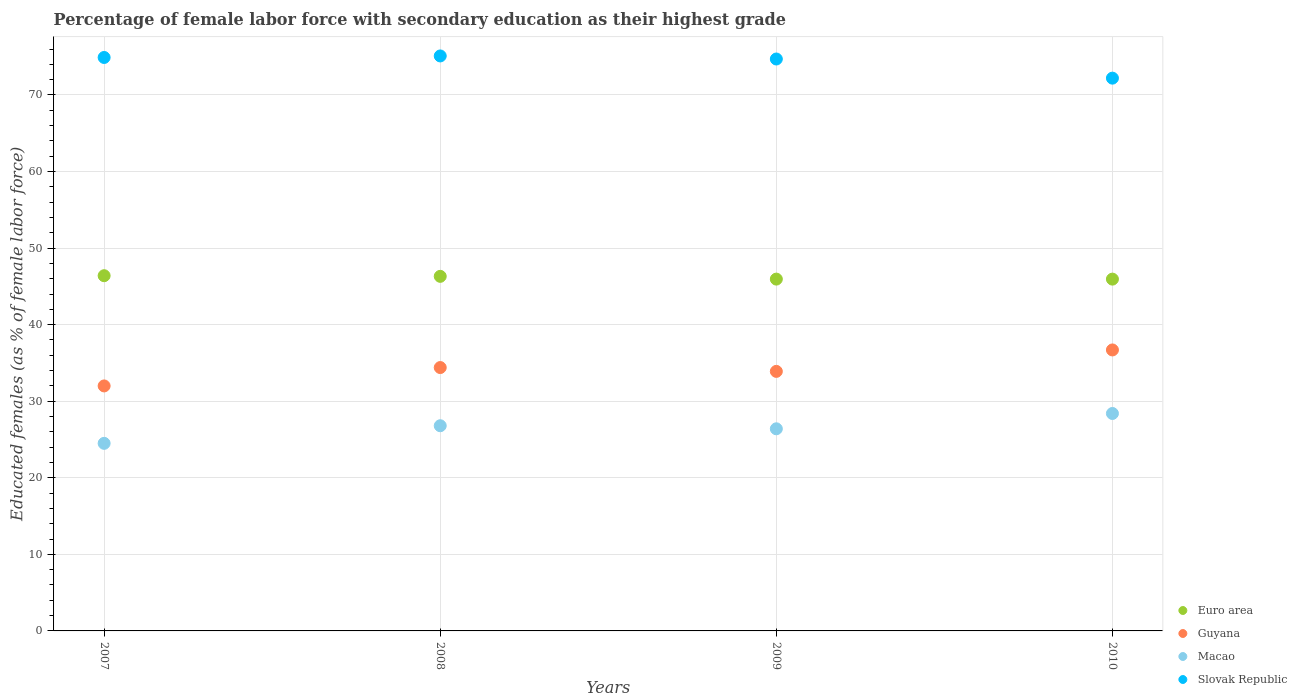Is the number of dotlines equal to the number of legend labels?
Your response must be concise. Yes. What is the percentage of female labor force with secondary education in Macao in 2009?
Offer a very short reply. 26.4. Across all years, what is the maximum percentage of female labor force with secondary education in Slovak Republic?
Your answer should be very brief. 75.1. In which year was the percentage of female labor force with secondary education in Guyana maximum?
Ensure brevity in your answer.  2010. In which year was the percentage of female labor force with secondary education in Euro area minimum?
Give a very brief answer. 2010. What is the total percentage of female labor force with secondary education in Macao in the graph?
Make the answer very short. 106.1. What is the difference between the percentage of female labor force with secondary education in Macao in 2007 and that in 2009?
Give a very brief answer. -1.9. What is the difference between the percentage of female labor force with secondary education in Macao in 2007 and the percentage of female labor force with secondary education in Guyana in 2010?
Offer a very short reply. -12.2. What is the average percentage of female labor force with secondary education in Slovak Republic per year?
Offer a very short reply. 74.22. In the year 2008, what is the difference between the percentage of female labor force with secondary education in Guyana and percentage of female labor force with secondary education in Euro area?
Keep it short and to the point. -11.91. In how many years, is the percentage of female labor force with secondary education in Guyana greater than 42 %?
Offer a very short reply. 0. What is the ratio of the percentage of female labor force with secondary education in Euro area in 2007 to that in 2009?
Your response must be concise. 1.01. What is the difference between the highest and the second highest percentage of female labor force with secondary education in Guyana?
Provide a succinct answer. 2.3. What is the difference between the highest and the lowest percentage of female labor force with secondary education in Slovak Republic?
Keep it short and to the point. 2.9. Is the sum of the percentage of female labor force with secondary education in Macao in 2007 and 2009 greater than the maximum percentage of female labor force with secondary education in Euro area across all years?
Make the answer very short. Yes. Is it the case that in every year, the sum of the percentage of female labor force with secondary education in Euro area and percentage of female labor force with secondary education in Guyana  is greater than the sum of percentage of female labor force with secondary education in Slovak Republic and percentage of female labor force with secondary education in Macao?
Your answer should be very brief. No. Is it the case that in every year, the sum of the percentage of female labor force with secondary education in Euro area and percentage of female labor force with secondary education in Guyana  is greater than the percentage of female labor force with secondary education in Slovak Republic?
Give a very brief answer. Yes. How many years are there in the graph?
Offer a terse response. 4. Does the graph contain any zero values?
Offer a very short reply. No. How many legend labels are there?
Provide a succinct answer. 4. How are the legend labels stacked?
Keep it short and to the point. Vertical. What is the title of the graph?
Your answer should be very brief. Percentage of female labor force with secondary education as their highest grade. What is the label or title of the Y-axis?
Provide a succinct answer. Educated females (as % of female labor force). What is the Educated females (as % of female labor force) in Euro area in 2007?
Your answer should be very brief. 46.4. What is the Educated females (as % of female labor force) of Guyana in 2007?
Your answer should be very brief. 32. What is the Educated females (as % of female labor force) in Slovak Republic in 2007?
Your response must be concise. 74.9. What is the Educated females (as % of female labor force) in Euro area in 2008?
Offer a very short reply. 46.31. What is the Educated females (as % of female labor force) in Guyana in 2008?
Your answer should be very brief. 34.4. What is the Educated females (as % of female labor force) in Macao in 2008?
Give a very brief answer. 26.8. What is the Educated females (as % of female labor force) in Slovak Republic in 2008?
Provide a succinct answer. 75.1. What is the Educated females (as % of female labor force) of Euro area in 2009?
Offer a very short reply. 45.95. What is the Educated females (as % of female labor force) of Guyana in 2009?
Your answer should be very brief. 33.9. What is the Educated females (as % of female labor force) of Macao in 2009?
Provide a succinct answer. 26.4. What is the Educated females (as % of female labor force) of Slovak Republic in 2009?
Ensure brevity in your answer.  74.7. What is the Educated females (as % of female labor force) of Euro area in 2010?
Give a very brief answer. 45.95. What is the Educated females (as % of female labor force) in Guyana in 2010?
Make the answer very short. 36.7. What is the Educated females (as % of female labor force) of Macao in 2010?
Offer a terse response. 28.4. What is the Educated females (as % of female labor force) of Slovak Republic in 2010?
Make the answer very short. 72.2. Across all years, what is the maximum Educated females (as % of female labor force) of Euro area?
Make the answer very short. 46.4. Across all years, what is the maximum Educated females (as % of female labor force) of Guyana?
Keep it short and to the point. 36.7. Across all years, what is the maximum Educated females (as % of female labor force) in Macao?
Keep it short and to the point. 28.4. Across all years, what is the maximum Educated females (as % of female labor force) of Slovak Republic?
Provide a succinct answer. 75.1. Across all years, what is the minimum Educated females (as % of female labor force) in Euro area?
Keep it short and to the point. 45.95. Across all years, what is the minimum Educated females (as % of female labor force) in Slovak Republic?
Give a very brief answer. 72.2. What is the total Educated females (as % of female labor force) in Euro area in the graph?
Offer a very short reply. 184.61. What is the total Educated females (as % of female labor force) in Guyana in the graph?
Your answer should be very brief. 137. What is the total Educated females (as % of female labor force) in Macao in the graph?
Your answer should be very brief. 106.1. What is the total Educated females (as % of female labor force) in Slovak Republic in the graph?
Your answer should be compact. 296.9. What is the difference between the Educated females (as % of female labor force) in Euro area in 2007 and that in 2008?
Ensure brevity in your answer.  0.08. What is the difference between the Educated females (as % of female labor force) in Guyana in 2007 and that in 2008?
Provide a short and direct response. -2.4. What is the difference between the Educated females (as % of female labor force) of Macao in 2007 and that in 2008?
Offer a terse response. -2.3. What is the difference between the Educated females (as % of female labor force) of Euro area in 2007 and that in 2009?
Make the answer very short. 0.44. What is the difference between the Educated females (as % of female labor force) of Slovak Republic in 2007 and that in 2009?
Offer a terse response. 0.2. What is the difference between the Educated females (as % of female labor force) of Euro area in 2007 and that in 2010?
Offer a terse response. 0.45. What is the difference between the Educated females (as % of female labor force) in Guyana in 2007 and that in 2010?
Your answer should be very brief. -4.7. What is the difference between the Educated females (as % of female labor force) of Slovak Republic in 2007 and that in 2010?
Offer a very short reply. 2.7. What is the difference between the Educated females (as % of female labor force) in Euro area in 2008 and that in 2009?
Offer a very short reply. 0.36. What is the difference between the Educated females (as % of female labor force) of Euro area in 2008 and that in 2010?
Offer a terse response. 0.36. What is the difference between the Educated females (as % of female labor force) of Slovak Republic in 2008 and that in 2010?
Provide a succinct answer. 2.9. What is the difference between the Educated females (as % of female labor force) of Euro area in 2009 and that in 2010?
Offer a very short reply. 0. What is the difference between the Educated females (as % of female labor force) in Guyana in 2009 and that in 2010?
Offer a terse response. -2.8. What is the difference between the Educated females (as % of female labor force) of Euro area in 2007 and the Educated females (as % of female labor force) of Guyana in 2008?
Give a very brief answer. 12. What is the difference between the Educated females (as % of female labor force) of Euro area in 2007 and the Educated females (as % of female labor force) of Macao in 2008?
Provide a short and direct response. 19.6. What is the difference between the Educated females (as % of female labor force) in Euro area in 2007 and the Educated females (as % of female labor force) in Slovak Republic in 2008?
Give a very brief answer. -28.7. What is the difference between the Educated females (as % of female labor force) of Guyana in 2007 and the Educated females (as % of female labor force) of Macao in 2008?
Your answer should be compact. 5.2. What is the difference between the Educated females (as % of female labor force) in Guyana in 2007 and the Educated females (as % of female labor force) in Slovak Republic in 2008?
Make the answer very short. -43.1. What is the difference between the Educated females (as % of female labor force) in Macao in 2007 and the Educated females (as % of female labor force) in Slovak Republic in 2008?
Your answer should be compact. -50.6. What is the difference between the Educated females (as % of female labor force) in Euro area in 2007 and the Educated females (as % of female labor force) in Guyana in 2009?
Provide a succinct answer. 12.5. What is the difference between the Educated females (as % of female labor force) in Euro area in 2007 and the Educated females (as % of female labor force) in Macao in 2009?
Keep it short and to the point. 20. What is the difference between the Educated females (as % of female labor force) in Euro area in 2007 and the Educated females (as % of female labor force) in Slovak Republic in 2009?
Provide a short and direct response. -28.3. What is the difference between the Educated females (as % of female labor force) of Guyana in 2007 and the Educated females (as % of female labor force) of Macao in 2009?
Your answer should be very brief. 5.6. What is the difference between the Educated females (as % of female labor force) of Guyana in 2007 and the Educated females (as % of female labor force) of Slovak Republic in 2009?
Offer a terse response. -42.7. What is the difference between the Educated females (as % of female labor force) in Macao in 2007 and the Educated females (as % of female labor force) in Slovak Republic in 2009?
Keep it short and to the point. -50.2. What is the difference between the Educated females (as % of female labor force) in Euro area in 2007 and the Educated females (as % of female labor force) in Guyana in 2010?
Provide a short and direct response. 9.7. What is the difference between the Educated females (as % of female labor force) in Euro area in 2007 and the Educated females (as % of female labor force) in Macao in 2010?
Your response must be concise. 18. What is the difference between the Educated females (as % of female labor force) of Euro area in 2007 and the Educated females (as % of female labor force) of Slovak Republic in 2010?
Your answer should be very brief. -25.8. What is the difference between the Educated females (as % of female labor force) in Guyana in 2007 and the Educated females (as % of female labor force) in Macao in 2010?
Offer a terse response. 3.6. What is the difference between the Educated females (as % of female labor force) of Guyana in 2007 and the Educated females (as % of female labor force) of Slovak Republic in 2010?
Provide a succinct answer. -40.2. What is the difference between the Educated females (as % of female labor force) in Macao in 2007 and the Educated females (as % of female labor force) in Slovak Republic in 2010?
Give a very brief answer. -47.7. What is the difference between the Educated females (as % of female labor force) of Euro area in 2008 and the Educated females (as % of female labor force) of Guyana in 2009?
Keep it short and to the point. 12.41. What is the difference between the Educated females (as % of female labor force) in Euro area in 2008 and the Educated females (as % of female labor force) in Macao in 2009?
Provide a succinct answer. 19.91. What is the difference between the Educated females (as % of female labor force) of Euro area in 2008 and the Educated females (as % of female labor force) of Slovak Republic in 2009?
Offer a terse response. -28.39. What is the difference between the Educated females (as % of female labor force) of Guyana in 2008 and the Educated females (as % of female labor force) of Slovak Republic in 2009?
Provide a short and direct response. -40.3. What is the difference between the Educated females (as % of female labor force) in Macao in 2008 and the Educated females (as % of female labor force) in Slovak Republic in 2009?
Keep it short and to the point. -47.9. What is the difference between the Educated females (as % of female labor force) of Euro area in 2008 and the Educated females (as % of female labor force) of Guyana in 2010?
Your answer should be compact. 9.61. What is the difference between the Educated females (as % of female labor force) of Euro area in 2008 and the Educated females (as % of female labor force) of Macao in 2010?
Give a very brief answer. 17.91. What is the difference between the Educated females (as % of female labor force) of Euro area in 2008 and the Educated females (as % of female labor force) of Slovak Republic in 2010?
Make the answer very short. -25.89. What is the difference between the Educated females (as % of female labor force) of Guyana in 2008 and the Educated females (as % of female labor force) of Macao in 2010?
Your response must be concise. 6. What is the difference between the Educated females (as % of female labor force) of Guyana in 2008 and the Educated females (as % of female labor force) of Slovak Republic in 2010?
Your answer should be compact. -37.8. What is the difference between the Educated females (as % of female labor force) in Macao in 2008 and the Educated females (as % of female labor force) in Slovak Republic in 2010?
Your response must be concise. -45.4. What is the difference between the Educated females (as % of female labor force) of Euro area in 2009 and the Educated females (as % of female labor force) of Guyana in 2010?
Make the answer very short. 9.25. What is the difference between the Educated females (as % of female labor force) in Euro area in 2009 and the Educated females (as % of female labor force) in Macao in 2010?
Offer a terse response. 17.55. What is the difference between the Educated females (as % of female labor force) in Euro area in 2009 and the Educated females (as % of female labor force) in Slovak Republic in 2010?
Offer a terse response. -26.25. What is the difference between the Educated females (as % of female labor force) in Guyana in 2009 and the Educated females (as % of female labor force) in Slovak Republic in 2010?
Keep it short and to the point. -38.3. What is the difference between the Educated females (as % of female labor force) in Macao in 2009 and the Educated females (as % of female labor force) in Slovak Republic in 2010?
Give a very brief answer. -45.8. What is the average Educated females (as % of female labor force) in Euro area per year?
Your answer should be compact. 46.15. What is the average Educated females (as % of female labor force) in Guyana per year?
Your response must be concise. 34.25. What is the average Educated females (as % of female labor force) of Macao per year?
Keep it short and to the point. 26.52. What is the average Educated females (as % of female labor force) in Slovak Republic per year?
Ensure brevity in your answer.  74.22. In the year 2007, what is the difference between the Educated females (as % of female labor force) of Euro area and Educated females (as % of female labor force) of Guyana?
Your answer should be compact. 14.4. In the year 2007, what is the difference between the Educated females (as % of female labor force) of Euro area and Educated females (as % of female labor force) of Macao?
Your answer should be compact. 21.9. In the year 2007, what is the difference between the Educated females (as % of female labor force) in Euro area and Educated females (as % of female labor force) in Slovak Republic?
Offer a very short reply. -28.5. In the year 2007, what is the difference between the Educated females (as % of female labor force) of Guyana and Educated females (as % of female labor force) of Slovak Republic?
Provide a succinct answer. -42.9. In the year 2007, what is the difference between the Educated females (as % of female labor force) in Macao and Educated females (as % of female labor force) in Slovak Republic?
Your answer should be very brief. -50.4. In the year 2008, what is the difference between the Educated females (as % of female labor force) in Euro area and Educated females (as % of female labor force) in Guyana?
Your answer should be compact. 11.91. In the year 2008, what is the difference between the Educated females (as % of female labor force) in Euro area and Educated females (as % of female labor force) in Macao?
Make the answer very short. 19.51. In the year 2008, what is the difference between the Educated females (as % of female labor force) of Euro area and Educated females (as % of female labor force) of Slovak Republic?
Offer a terse response. -28.79. In the year 2008, what is the difference between the Educated females (as % of female labor force) in Guyana and Educated females (as % of female labor force) in Macao?
Make the answer very short. 7.6. In the year 2008, what is the difference between the Educated females (as % of female labor force) of Guyana and Educated females (as % of female labor force) of Slovak Republic?
Keep it short and to the point. -40.7. In the year 2008, what is the difference between the Educated females (as % of female labor force) of Macao and Educated females (as % of female labor force) of Slovak Republic?
Keep it short and to the point. -48.3. In the year 2009, what is the difference between the Educated females (as % of female labor force) in Euro area and Educated females (as % of female labor force) in Guyana?
Provide a short and direct response. 12.05. In the year 2009, what is the difference between the Educated females (as % of female labor force) in Euro area and Educated females (as % of female labor force) in Macao?
Your answer should be compact. 19.55. In the year 2009, what is the difference between the Educated females (as % of female labor force) in Euro area and Educated females (as % of female labor force) in Slovak Republic?
Offer a terse response. -28.75. In the year 2009, what is the difference between the Educated females (as % of female labor force) in Guyana and Educated females (as % of female labor force) in Macao?
Provide a succinct answer. 7.5. In the year 2009, what is the difference between the Educated females (as % of female labor force) of Guyana and Educated females (as % of female labor force) of Slovak Republic?
Provide a succinct answer. -40.8. In the year 2009, what is the difference between the Educated females (as % of female labor force) of Macao and Educated females (as % of female labor force) of Slovak Republic?
Your answer should be very brief. -48.3. In the year 2010, what is the difference between the Educated females (as % of female labor force) in Euro area and Educated females (as % of female labor force) in Guyana?
Keep it short and to the point. 9.25. In the year 2010, what is the difference between the Educated females (as % of female labor force) of Euro area and Educated females (as % of female labor force) of Macao?
Make the answer very short. 17.55. In the year 2010, what is the difference between the Educated females (as % of female labor force) in Euro area and Educated females (as % of female labor force) in Slovak Republic?
Make the answer very short. -26.25. In the year 2010, what is the difference between the Educated females (as % of female labor force) in Guyana and Educated females (as % of female labor force) in Slovak Republic?
Give a very brief answer. -35.5. In the year 2010, what is the difference between the Educated females (as % of female labor force) in Macao and Educated females (as % of female labor force) in Slovak Republic?
Provide a succinct answer. -43.8. What is the ratio of the Educated females (as % of female labor force) in Guyana in 2007 to that in 2008?
Offer a terse response. 0.93. What is the ratio of the Educated females (as % of female labor force) in Macao in 2007 to that in 2008?
Offer a terse response. 0.91. What is the ratio of the Educated females (as % of female labor force) in Euro area in 2007 to that in 2009?
Your answer should be very brief. 1.01. What is the ratio of the Educated females (as % of female labor force) of Guyana in 2007 to that in 2009?
Offer a very short reply. 0.94. What is the ratio of the Educated females (as % of female labor force) in Macao in 2007 to that in 2009?
Offer a very short reply. 0.93. What is the ratio of the Educated females (as % of female labor force) in Euro area in 2007 to that in 2010?
Provide a short and direct response. 1.01. What is the ratio of the Educated females (as % of female labor force) in Guyana in 2007 to that in 2010?
Your answer should be very brief. 0.87. What is the ratio of the Educated females (as % of female labor force) of Macao in 2007 to that in 2010?
Keep it short and to the point. 0.86. What is the ratio of the Educated females (as % of female labor force) of Slovak Republic in 2007 to that in 2010?
Keep it short and to the point. 1.04. What is the ratio of the Educated females (as % of female labor force) of Euro area in 2008 to that in 2009?
Give a very brief answer. 1.01. What is the ratio of the Educated females (as % of female labor force) in Guyana in 2008 to that in 2009?
Offer a terse response. 1.01. What is the ratio of the Educated females (as % of female labor force) of Macao in 2008 to that in 2009?
Give a very brief answer. 1.02. What is the ratio of the Educated females (as % of female labor force) of Slovak Republic in 2008 to that in 2009?
Provide a short and direct response. 1.01. What is the ratio of the Educated females (as % of female labor force) of Euro area in 2008 to that in 2010?
Your response must be concise. 1.01. What is the ratio of the Educated females (as % of female labor force) of Guyana in 2008 to that in 2010?
Provide a short and direct response. 0.94. What is the ratio of the Educated females (as % of female labor force) in Macao in 2008 to that in 2010?
Give a very brief answer. 0.94. What is the ratio of the Educated females (as % of female labor force) of Slovak Republic in 2008 to that in 2010?
Give a very brief answer. 1.04. What is the ratio of the Educated females (as % of female labor force) in Guyana in 2009 to that in 2010?
Make the answer very short. 0.92. What is the ratio of the Educated females (as % of female labor force) in Macao in 2009 to that in 2010?
Give a very brief answer. 0.93. What is the ratio of the Educated females (as % of female labor force) of Slovak Republic in 2009 to that in 2010?
Provide a succinct answer. 1.03. What is the difference between the highest and the second highest Educated females (as % of female labor force) in Euro area?
Make the answer very short. 0.08. What is the difference between the highest and the second highest Educated females (as % of female labor force) in Guyana?
Make the answer very short. 2.3. What is the difference between the highest and the lowest Educated females (as % of female labor force) of Euro area?
Ensure brevity in your answer.  0.45. What is the difference between the highest and the lowest Educated females (as % of female labor force) of Macao?
Ensure brevity in your answer.  3.9. What is the difference between the highest and the lowest Educated females (as % of female labor force) in Slovak Republic?
Your answer should be compact. 2.9. 